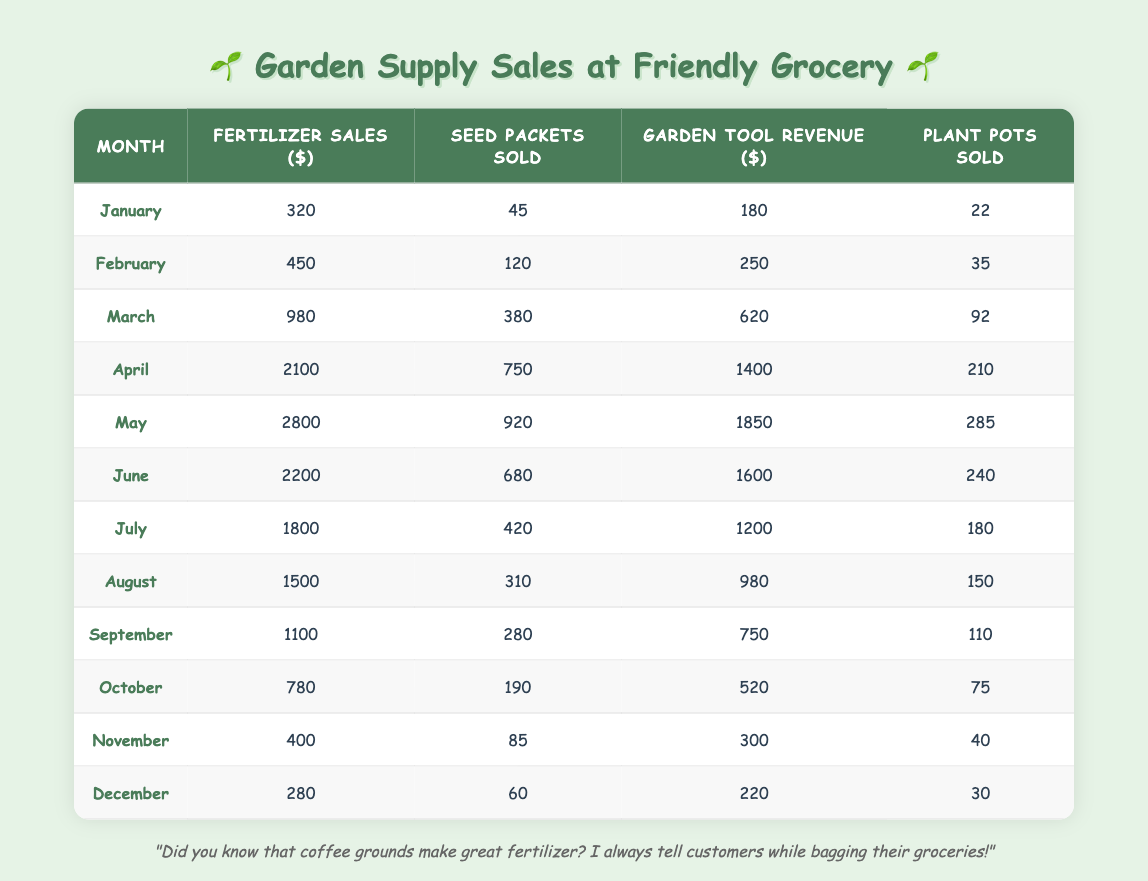What was the highest revenue generated from fertilizer sales in a month? Looking at the table, the highest value under "Fertilizer Sales ($)" is 2800, which corresponds to May.
Answer: 2800 In which month were the most seed packets sold? By examining the "Seed Packets Sold" column, the highest value is 920, which occurs in May.
Answer: May What is the total revenue from garden tools sold across all months? To find the total garden tool revenue, sum the values in the "Garden Tool Revenue ($)" column: 180 + 250 + 620 + 1400 + 1850 + 1600 + 1200 + 980 + 750 + 520 + 300 + 220 = 10370.
Answer: 10370 Did fertilizer sales decrease from April to May? Comparing the fertilizer sales from April (2100) to May (2800), we see that the sales actually increased. Therefore, the answer is no.
Answer: No What is the average number of plant pots sold per month? Sum the "Plant Pots Sold" values: 22 + 35 + 92 + 210 + 285 + 240 + 180 + 150 + 110 + 75 + 40 + 30 = 1269. Divide this by the number of months (12) to get the average: 1269 / 12 = 105.75.
Answer: 105.75 Which month had the lowest total sales across all categories? To determine the month with the lowest total sales, calculate the sum of each month's sales (fertilizer, seeds, tools, pots) and compare them. January has the total sales of 320 + 45 + 180 + 22 = 567, the lowest total.
Answer: January How many more seed packets were sold in April than in November? The number of seed packets sold in April is 750 and in November is 85. The difference is 750 - 85 = 665.
Answer: 665 Was there an increase in plant pots sold between June and July? Checking the "Plant Pots Sold," June has 240 and July has 180. Since 240 > 180, there was a decrease, not an increase.
Answer: No What percentage of the total fertilizer sales does June account for? First, find the total fertilizer sales by summing the corresponding column: 320 + 450 + 980 + 2100 + 2800 + 2200 + 1800 + 1500 + 1100 + 780 + 400 + 280 =  15810. June's sales are 2200, so the percentage is (2200 / 15810) * 100 ≈ 13.92%.
Answer: Approximately 13.92% 